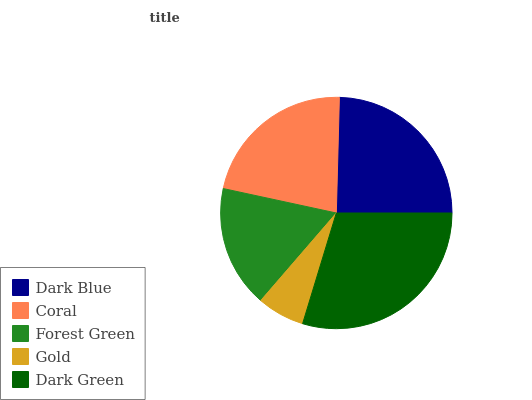Is Gold the minimum?
Answer yes or no. Yes. Is Dark Green the maximum?
Answer yes or no. Yes. Is Coral the minimum?
Answer yes or no. No. Is Coral the maximum?
Answer yes or no. No. Is Dark Blue greater than Coral?
Answer yes or no. Yes. Is Coral less than Dark Blue?
Answer yes or no. Yes. Is Coral greater than Dark Blue?
Answer yes or no. No. Is Dark Blue less than Coral?
Answer yes or no. No. Is Coral the high median?
Answer yes or no. Yes. Is Coral the low median?
Answer yes or no. Yes. Is Dark Green the high median?
Answer yes or no. No. Is Forest Green the low median?
Answer yes or no. No. 